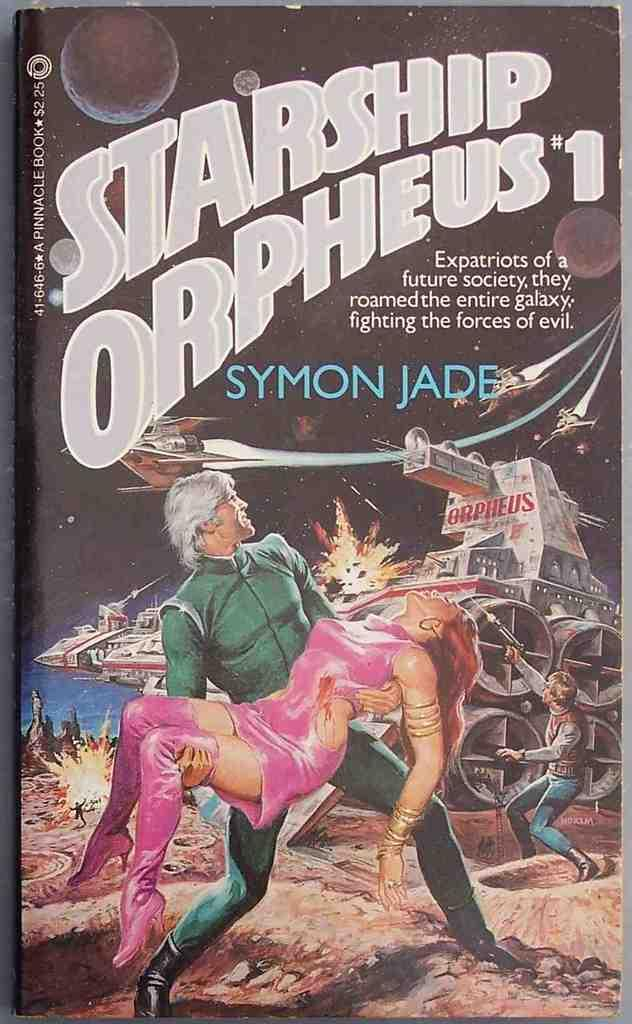What is the main subject of the book in the image? The book contains images of people and boats above the water. What type of content is included in the book? The book contains text and images. What position does the rifle have in the image? There is no rifle present in the image. 